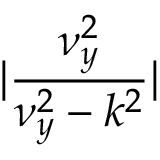Convert formula to latex. <formula><loc_0><loc_0><loc_500><loc_500>| \frac { \nu _ { y } ^ { 2 } } { \nu _ { y } ^ { 2 } - k ^ { 2 } } |</formula> 